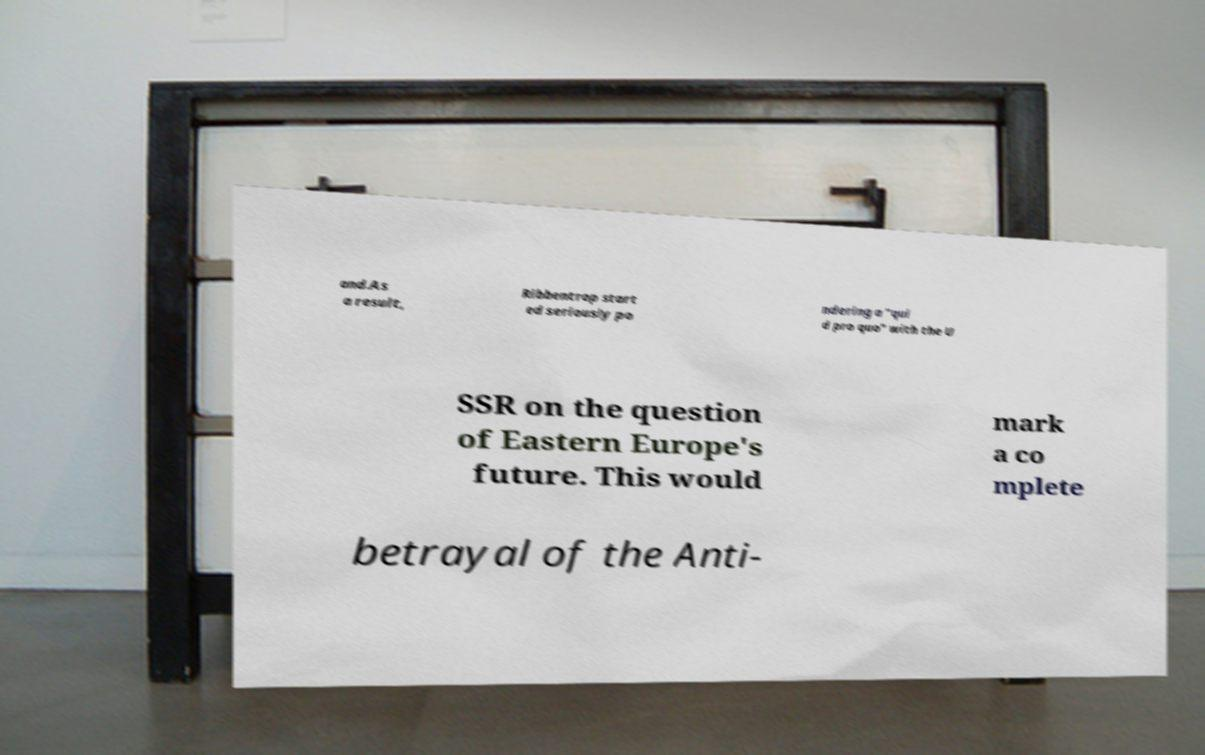Could you assist in decoding the text presented in this image and type it out clearly? and.As a result, Ribbentrop start ed seriously po ndering a "qui d pro quo" with the U SSR on the question of Eastern Europe's future. This would mark a co mplete betrayal of the Anti- 